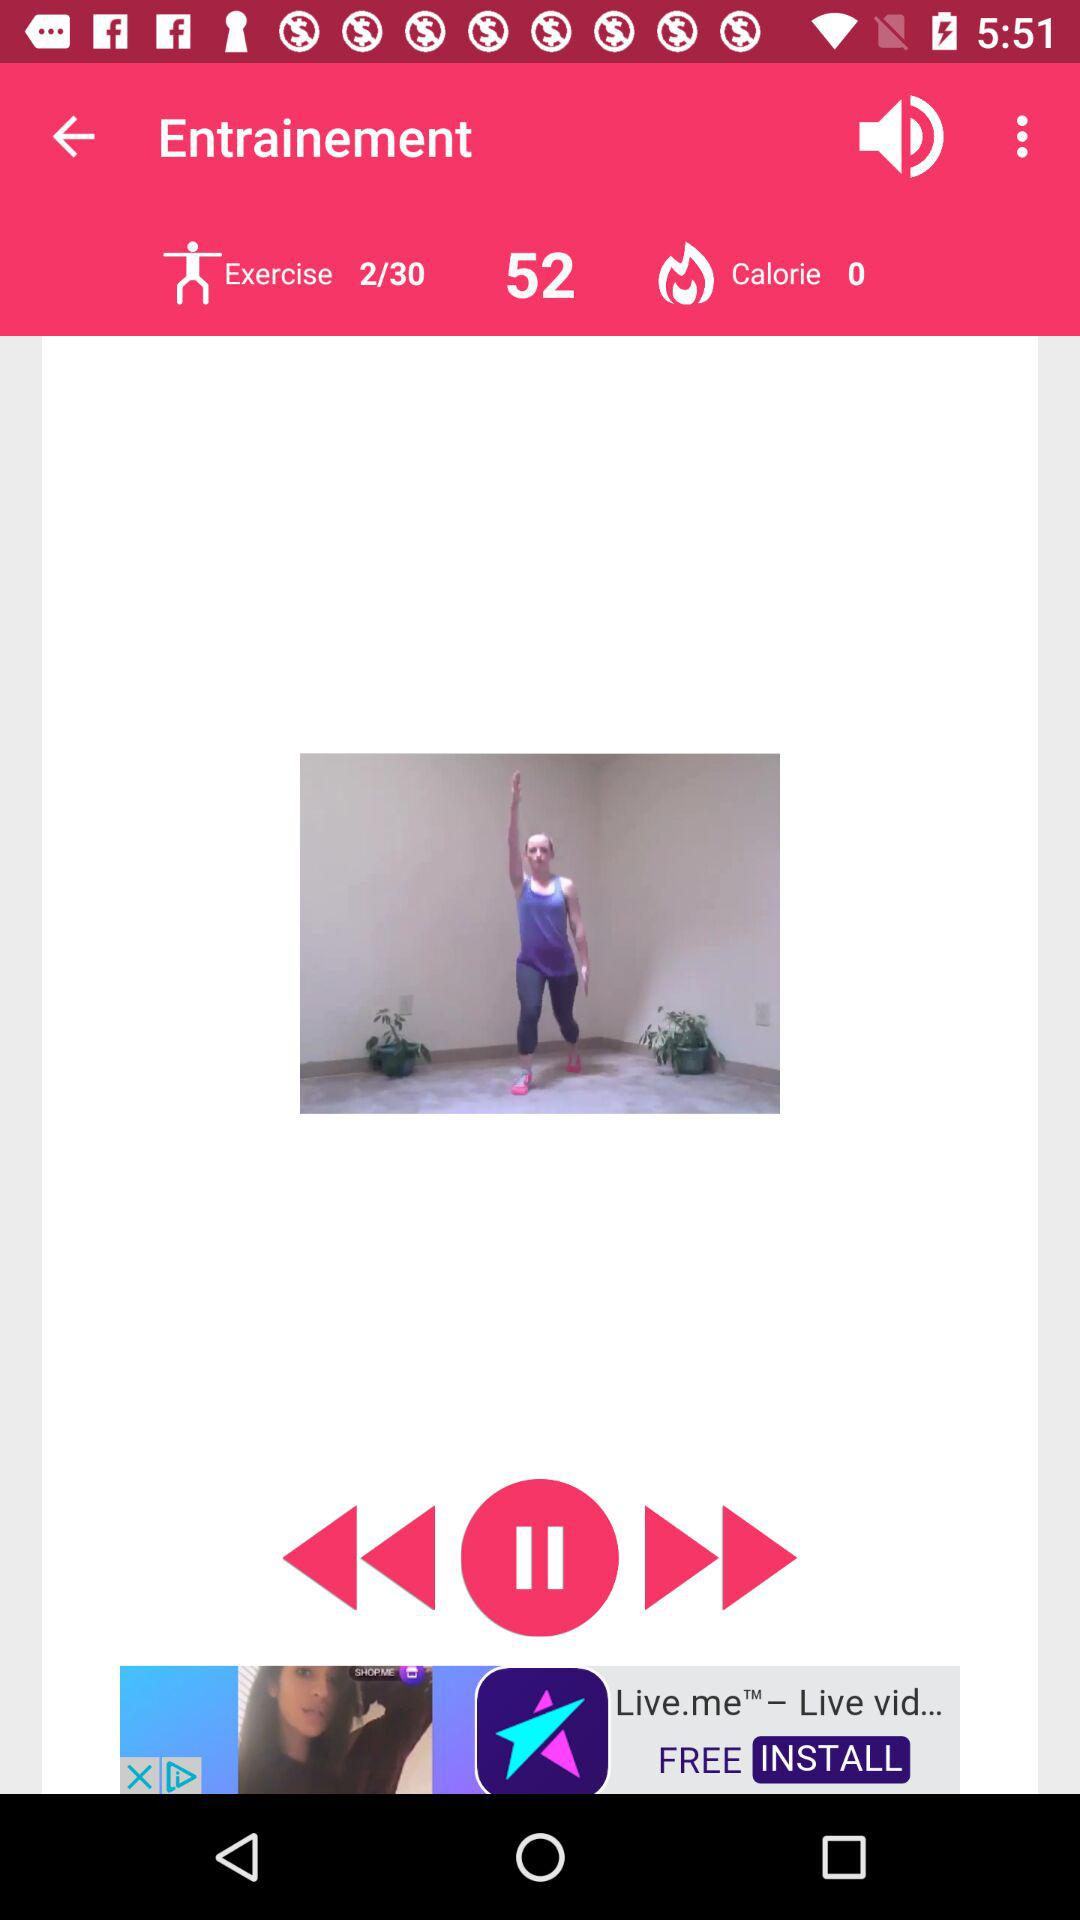What is the total number of exercises? The total number of exercises is 30. 